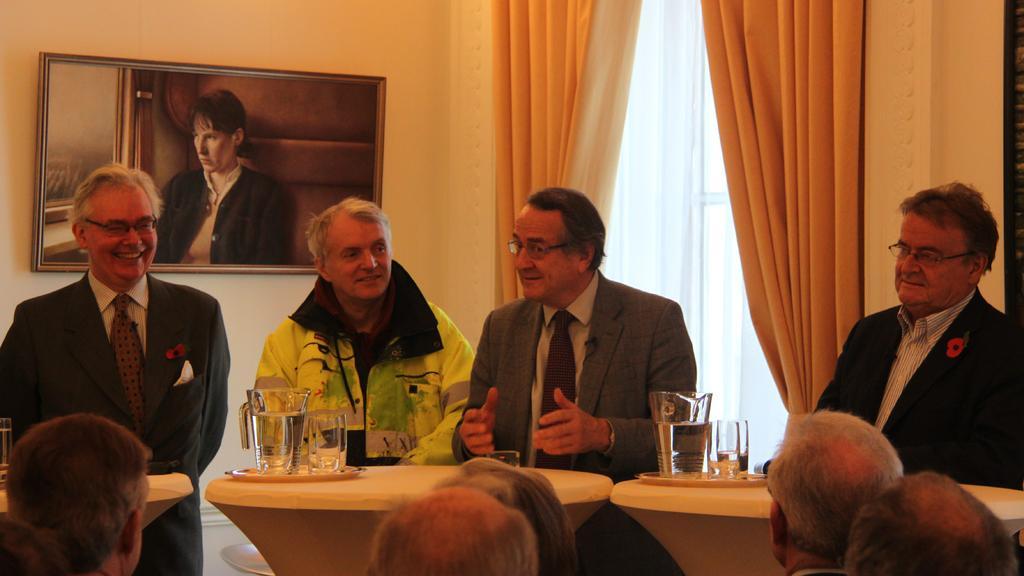Please provide a concise description of this image. In this picture we can see some people are in standing position in front of them there is a table on the table we have mug and glasses filled with water and opposite few people are sitting and watching to them. 